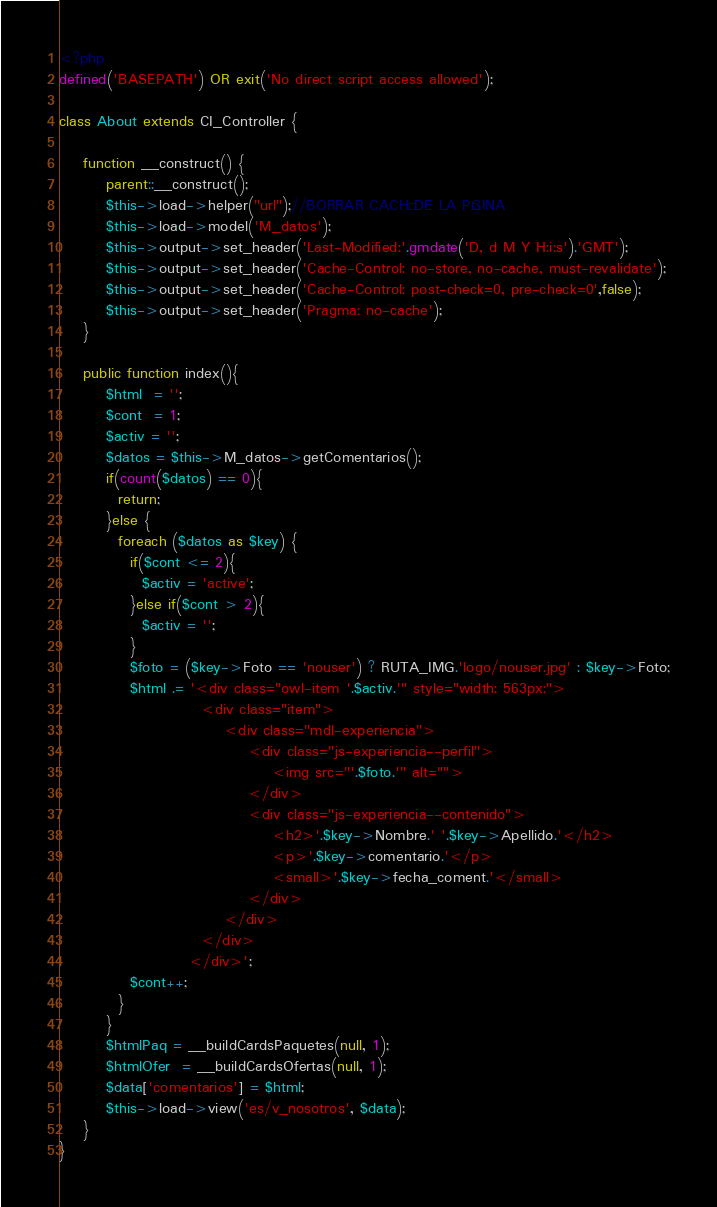Convert code to text. <code><loc_0><loc_0><loc_500><loc_500><_PHP_><?php
defined('BASEPATH') OR exit('No direct script access allowed');

class About extends CI_Controller {

	function __construct() {
        parent::__construct();
        $this->load->helper("url");//BORRAR CACHÉ DE LA PÁGINA
        $this->load->model('M_datos');
        $this->output->set_header('Last-Modified:'.gmdate('D, d M Y H:i:s').'GMT');
        $this->output->set_header('Cache-Control: no-store, no-cache, must-revalidate');
        $this->output->set_header('Cache-Control: post-check=0, pre-check=0',false);
        $this->output->set_header('Pragma: no-cache');
    }

	public function index(){
        $html  = '';
        $cont  = 1;
        $activ = '';
        $datos = $this->M_datos->getComentarios();
        if(count($datos) == 0){
          return;
        }else {
          foreach ($datos as $key) {
            if($cont <= 2){
              $activ = 'active';
            }else if($cont > 2){
              $activ = '';
            }
            $foto = ($key->Foto == 'nouser') ? RUTA_IMG.'logo/nouser.jpg' : $key->Foto;
            $html .= '<div class="owl-item '.$activ.'" style="width: 563px;">
                        <div class="item">
                            <div class="mdl-experiencia">
                                <div class="js-experiencia--perfil">
                                    <img src="'.$foto.'" alt="">
                                </div>
                                <div class="js-experiencia--contenido">
                                    <h2>'.$key->Nombre.' '.$key->Apellido.'</h2>
                                    <p>'.$key->comentario.'</p>
                                    <small>'.$key->fecha_coment.'</small>
                                </div>
                            </div>
                        </div>
                      </div>';
            $cont++;
          }
        }
        $htmlPaq = __buildCardsPaquetes(null, 1);
        $htmlOfer  = __buildCardsOfertas(null, 1);
        $data['comentarios'] = $html;
		$this->load->view('es/v_nosotros', $data);
	}
}</code> 